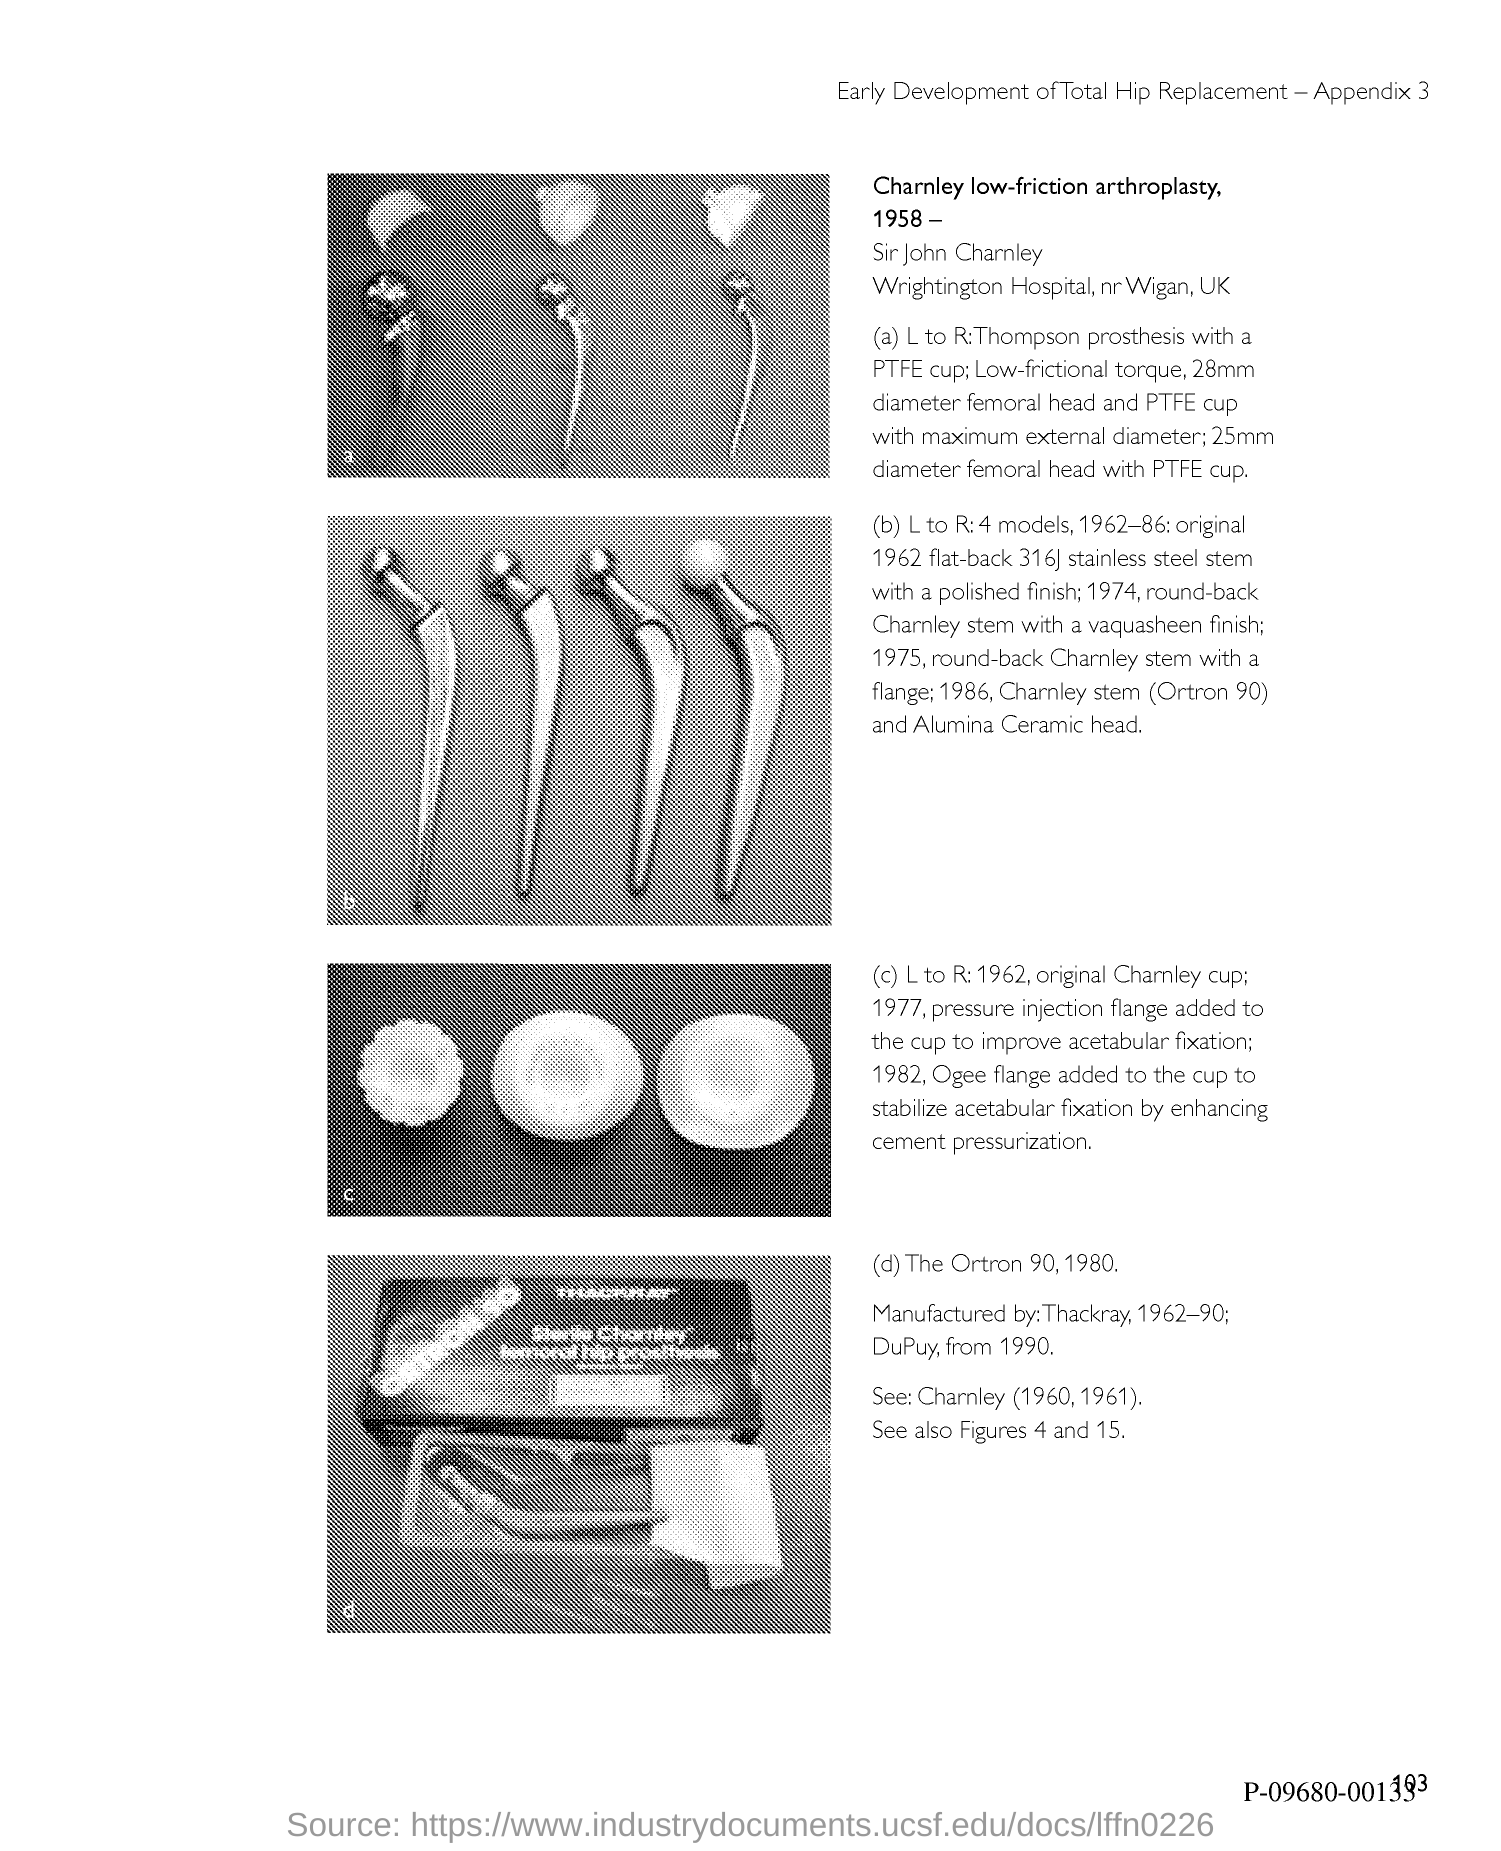Indicate a few pertinent items in this graphic. The appendix number is 3. 